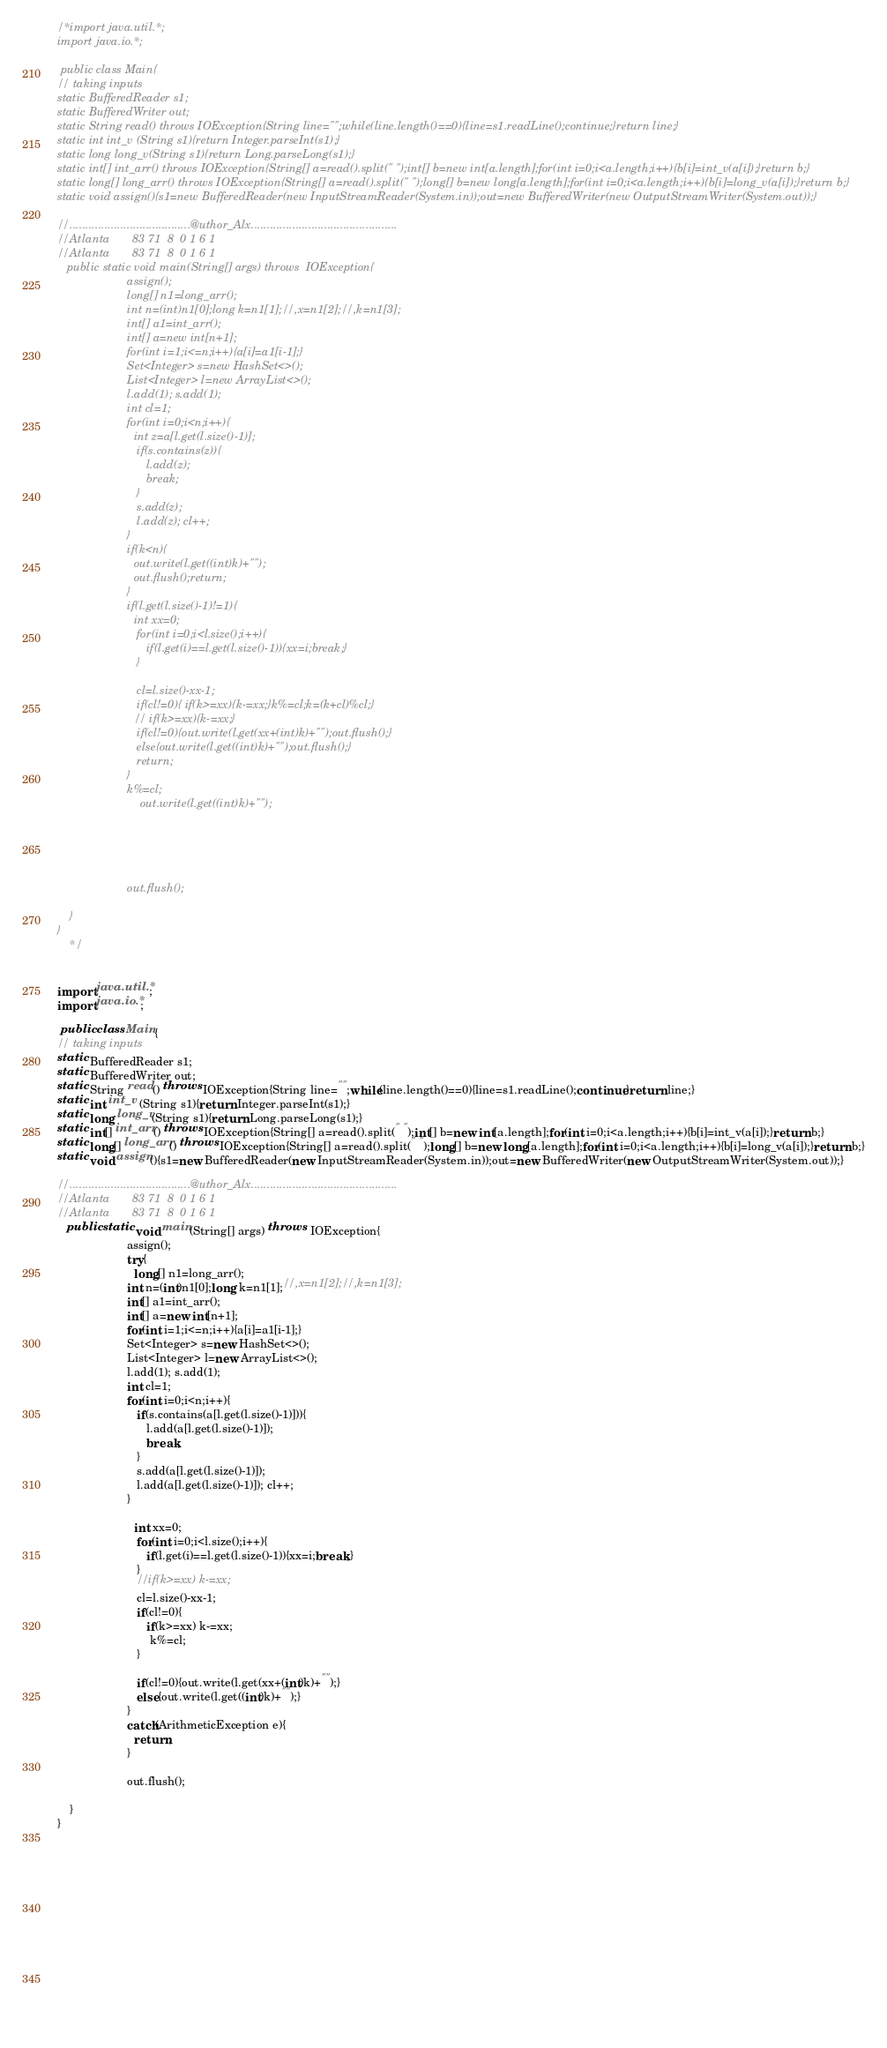Convert code to text. <code><loc_0><loc_0><loc_500><loc_500><_Java_>/*import java.util.*;
import java.io.*;

 public class Main{
// taking inputs
static BufferedReader s1;
static BufferedWriter out;
static String read() throws IOException{String line="";while(line.length()==0){line=s1.readLine();continue;}return line;}
static int int_v (String s1){return Integer.parseInt(s1);}
static long long_v(String s1){return Long.parseLong(s1);}
static int[] int_arr() throws IOException{String[] a=read().split(" ");int[] b=new int[a.length];for(int i=0;i<a.length;i++){b[i]=int_v(a[i]);}return b;}
static long[] long_arr() throws IOException{String[] a=read().split(" ");long[] b=new long[a.length];for(int i=0;i<a.length;i++){b[i]=long_v(a[i]);}return b;}
static void assign(){s1=new BufferedReader(new InputStreamReader(System.in));out=new BufferedWriter(new OutputStreamWriter(System.out));}

//......................................@uthor_Alx..............................................
//Atlanta       83 71  8  0 1 6 1
//Atlanta       83 71  8  0 1 6 1
   public static void main(String[] args) throws  IOException{
	        		  assign();
	        		  long[] n1=long_arr();
	        		  int n=(int)n1[0];long k=n1[1];//,x=n1[2];//,k=n1[3];
	        		  int[] a1=int_arr();
	        		  int[] a=new int[n+1];
	        		  for(int i=1;i<=n;i++){a[i]=a1[i-1];}
	        		  Set<Integer> s=new HashSet<>();
	        		  List<Integer> l=new ArrayList<>();
	        		  l.add(1); s.add(1);
	        		  int cl=1;
	        		  for(int i=0;i<n;i++){
	        		  	int z=a[l.get(l.size()-1)];
	        		  	 if(s.contains(z)){
	        		  	 	l.add(z);
	        		  	 	break;
	        		  	 }
	        		  	 s.add(z);
	        		  	 l.add(z); cl++;
	        		  }
	        		  if(k<n){
	        		  	out.write(l.get((int)k)+"");
	        		  	out.flush();return;
	        		  }
	        		  if(l.get(l.size()-1)!=1){
	        		  	int xx=0;
	        		  	 for(int i=0;i<l.size();i++){
	        		  	 	if(l.get(i)==l.get(l.size()-1)){xx=i;break;}
	        		  	 }

	        		  	 cl=l.size()-xx-1;
	        		  	 if(cl!=0){ if(k>=xx){k-=xx;}k%=cl;k=(k+cl)%cl;}
	        		  	// if(k>=xx){k-=xx;}
	        		  	 if(cl!=0){out.write(l.get(xx+(int)k)+"");out.flush();}
	        		  	 else{out.write(l.get((int)k)+"");out.flush();}
	        		  	 return;
	        		  }
	        		  k%=cl;
	        		  	  out.write(l.get((int)k)+"");
	        		  
	        		  
	        		  
	        		  
	        	
                      out.flush();
	        		 
	}
}
	*/       
	          

import java.util.*;
import java.io.*;

 public class Main{
// taking inputs
static BufferedReader s1;
static BufferedWriter out;
static String read() throws IOException{String line="";while(line.length()==0){line=s1.readLine();continue;}return line;}
static int int_v (String s1){return Integer.parseInt(s1);}
static long long_v(String s1){return Long.parseLong(s1);}
static int[] int_arr() throws IOException{String[] a=read().split(" ");int[] b=new int[a.length];for(int i=0;i<a.length;i++){b[i]=int_v(a[i]);}return b;}
static long[] long_arr() throws IOException{String[] a=read().split(" ");long[] b=new long[a.length];for(int i=0;i<a.length;i++){b[i]=long_v(a[i]);}return b;}
static void assign(){s1=new BufferedReader(new InputStreamReader(System.in));out=new BufferedWriter(new OutputStreamWriter(System.out));}

//......................................@uthor_Alx..............................................
//Atlanta       83 71  8  0 1 6 1
//Atlanta       83 71  8  0 1 6 1
   public static void main(String[] args) throws  IOException{
	        		  assign();
	        		  try{
	        		  	long[] n1=long_arr();
	        		  int n=(int)n1[0];long k=n1[1];//,x=n1[2];//,k=n1[3];
	        		  int[] a1=int_arr();
	        		  int[] a=new int[n+1];
	        		  for(int i=1;i<=n;i++){a[i]=a1[i-1];}
	        		  Set<Integer> s=new HashSet<>();
	        		  List<Integer> l=new ArrayList<>();
	        		  l.add(1); s.add(1);
	        		  int cl=1;
	        		  for(int i=0;i<n;i++){
	        		  	 if(s.contains(a[l.get(l.size()-1)])){
	        		  	 	l.add(a[l.get(l.size()-1)]);
	        		  	 	break;
	        		  	 }
	        		  	 s.add(a[l.get(l.size()-1)]);
	        		  	 l.add(a[l.get(l.size()-1)]); cl++;
	        		  }

	        		  	int xx=0;
	        		  	 for(int i=0;i<l.size();i++){
	        		  	 	if(l.get(i)==l.get(l.size()-1)){xx=i;break;}
	        		  	 }
	        		  	 //if(k>=xx) k-=xx;
	        		  	 cl=l.size()-xx-1;
	        		  	 if(cl!=0){
	        		  	 	if(k>=xx) k-=xx;
	        		  	 	 k%=cl;
	        		  	 }

	        		  	 if(cl!=0){out.write(l.get(xx+(int)k)+"");}
	        		  	 else{out.write(l.get((int)k)+"");}
	        		  }
	        		  catch(ArithmeticException e){
	        		  	return;
	        		  }

                      out.flush();
	        		 
	}
}
	       
	          



	
  





	
  



</code> 